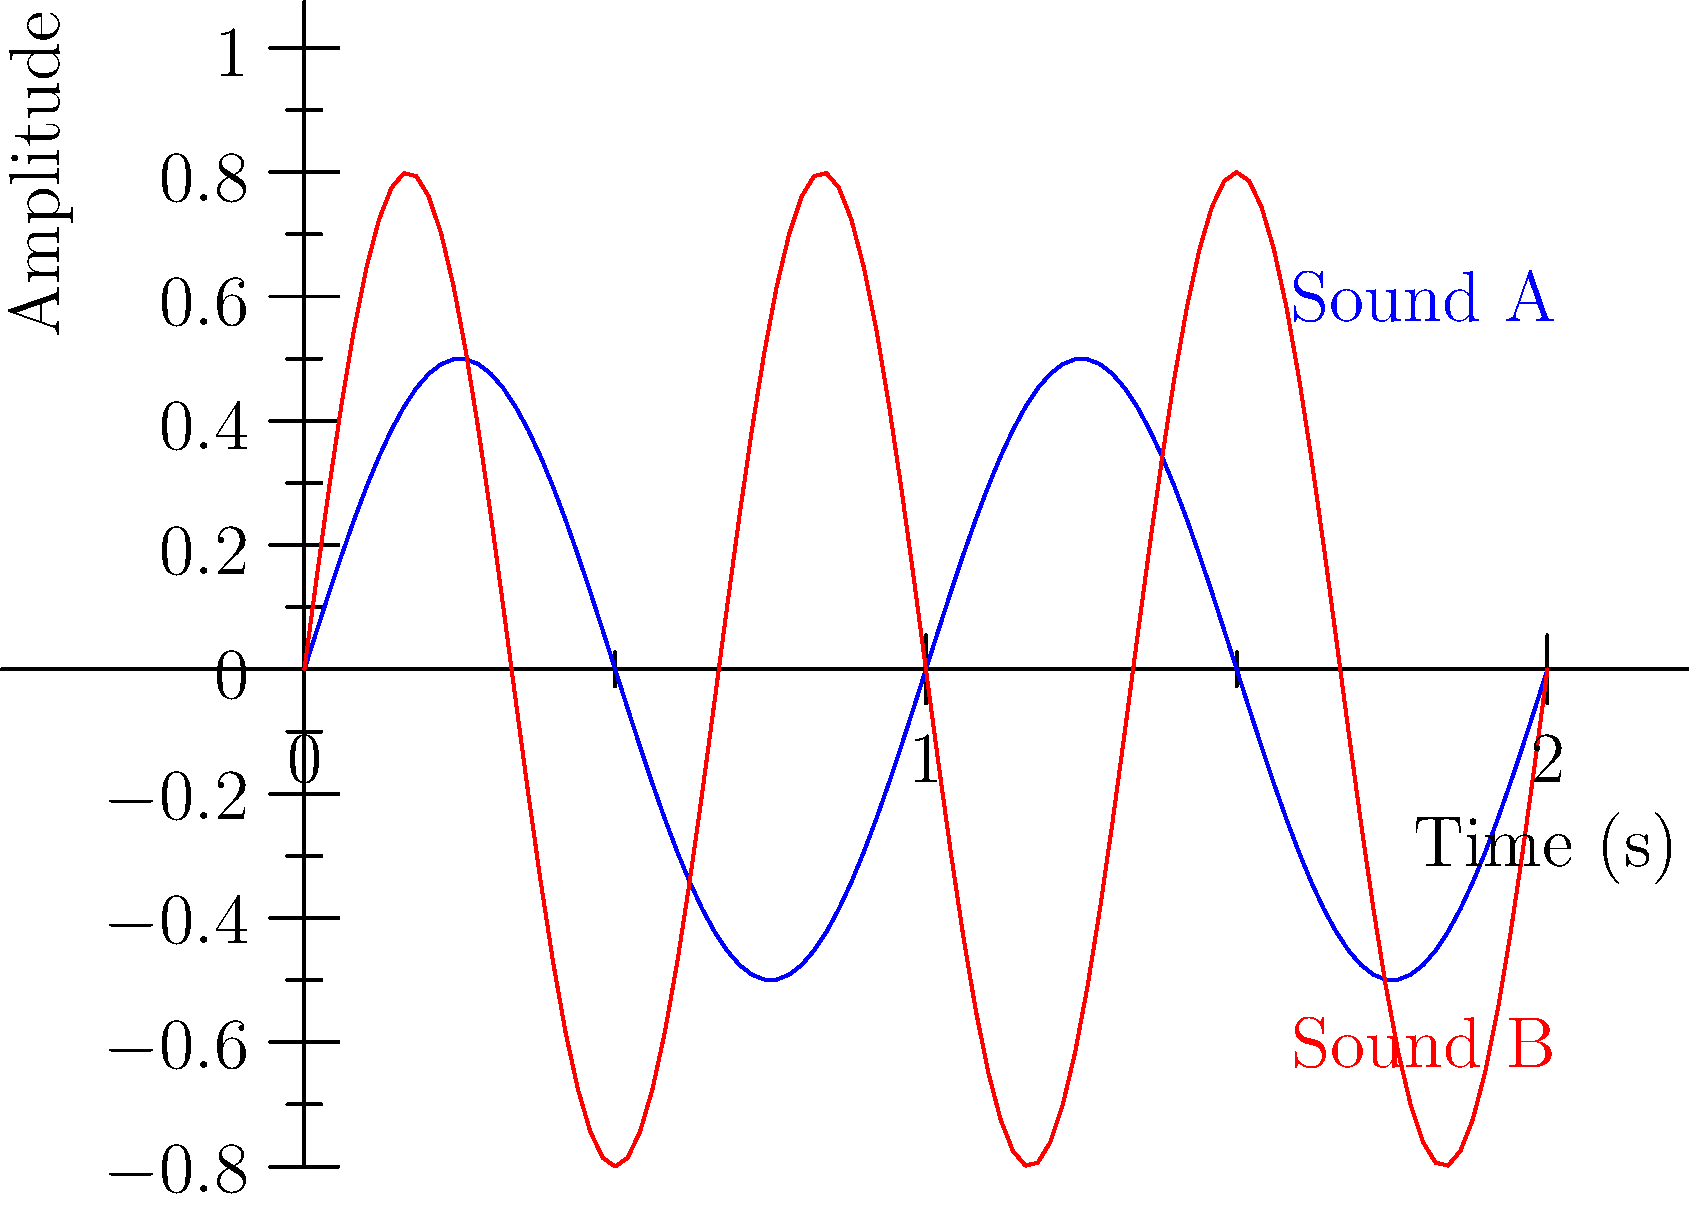Given the waveforms of two different sound effects (A and B) as shown in the graph, which sound effect has a higher frequency? To determine which sound effect has a higher frequency, we need to analyze the waveforms:

1. Frequency is related to the number of cycles completed in a given time period.
2. Observe that Sound A (blue) completes 2 full cycles in the given time frame.
3. Sound B (red) completes 3 full cycles in the same time frame.
4. More cycles in the same time period indicate a higher frequency.
5. Therefore, Sound B has a higher frequency than Sound A.

Additionally, we can observe that:
- Sound A has a longer wavelength (distance between peaks).
- Sound B has a shorter wavelength, which corresponds to a higher frequency.

The amplitude (height of the waves) is not relevant for determining frequency in this case.
Answer: Sound B 